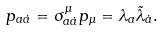Convert formula to latex. <formula><loc_0><loc_0><loc_500><loc_500>p _ { a \dot { a } } = \sigma ^ { \mu } _ { a \dot { a } } p _ { \mu } = \lambda _ { a } \tilde { \lambda } _ { \dot { a } } .</formula> 